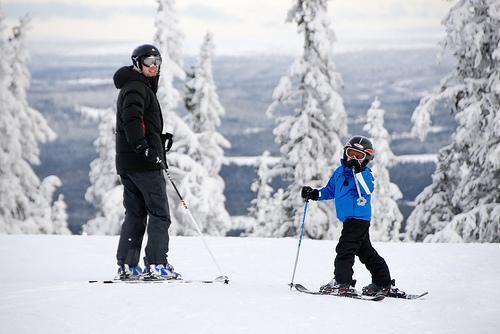How many people are in the picture?
Give a very brief answer. 2. 